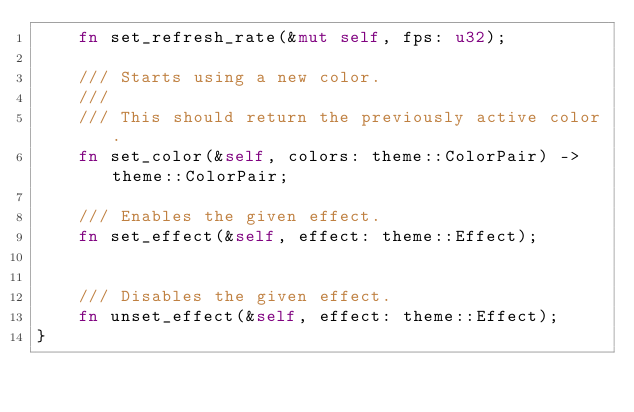<code> <loc_0><loc_0><loc_500><loc_500><_Rust_>    fn set_refresh_rate(&mut self, fps: u32);

    /// Starts using a new color.
    ///
    /// This should return the previously active color.
    fn set_color(&self, colors: theme::ColorPair) -> theme::ColorPair;

    /// Enables the given effect.
    fn set_effect(&self, effect: theme::Effect);


    /// Disables the given effect.
    fn unset_effect(&self, effect: theme::Effect);
}
</code> 